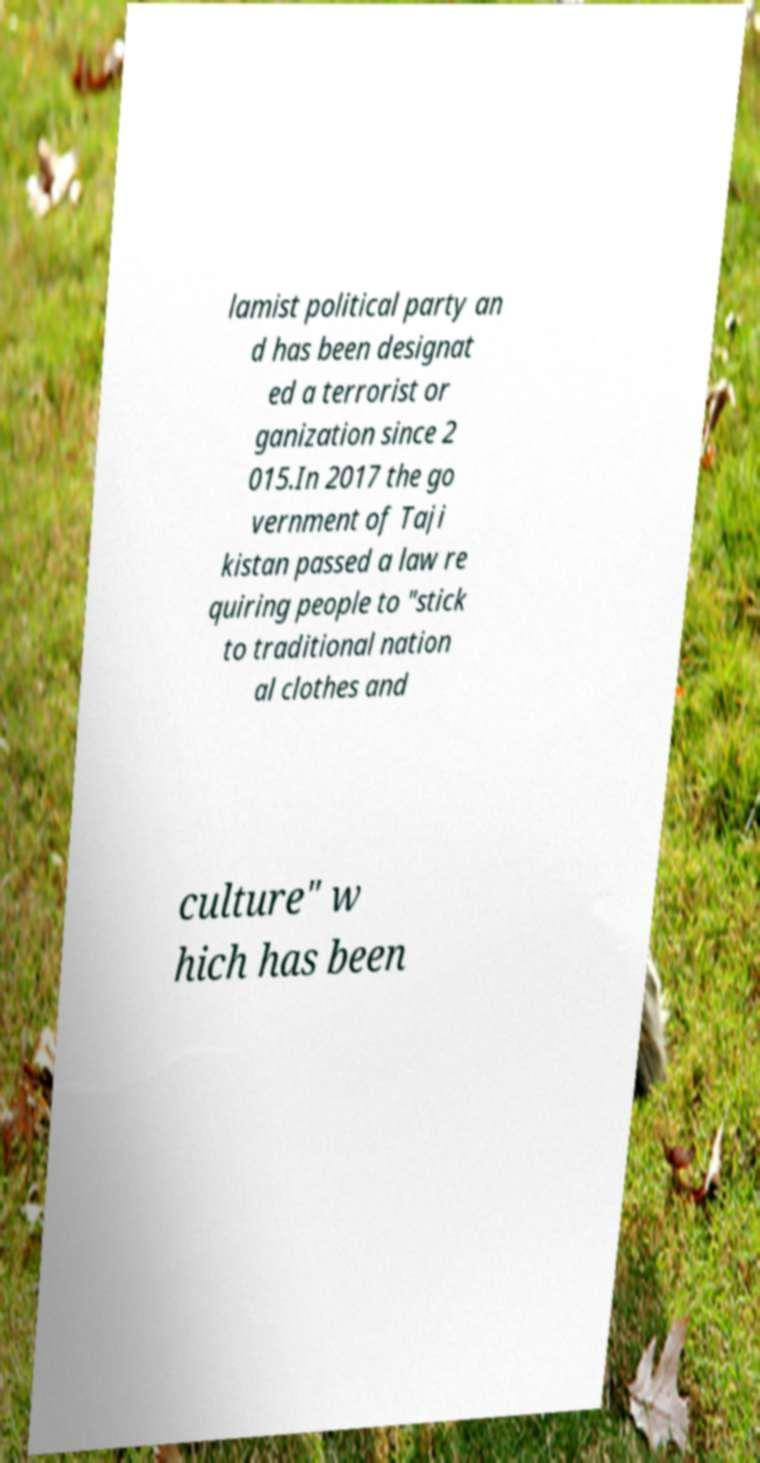For documentation purposes, I need the text within this image transcribed. Could you provide that? lamist political party an d has been designat ed a terrorist or ganization since 2 015.In 2017 the go vernment of Taji kistan passed a law re quiring people to "stick to traditional nation al clothes and culture" w hich has been 